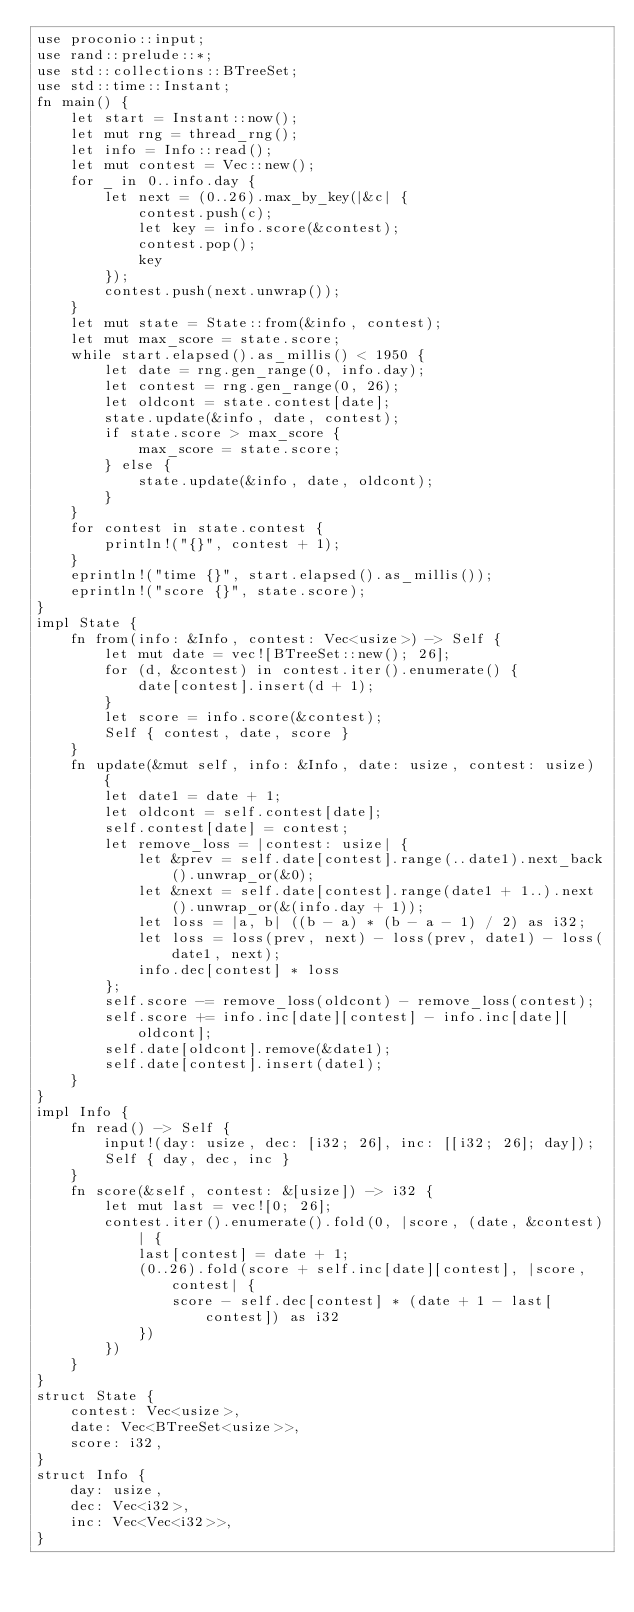Convert code to text. <code><loc_0><loc_0><loc_500><loc_500><_Rust_>use proconio::input;
use rand::prelude::*;
use std::collections::BTreeSet;
use std::time::Instant;
fn main() {
    let start = Instant::now();
    let mut rng = thread_rng();
    let info = Info::read();
    let mut contest = Vec::new();
    for _ in 0..info.day {
        let next = (0..26).max_by_key(|&c| {
            contest.push(c);
            let key = info.score(&contest);
            contest.pop();
            key
        });
        contest.push(next.unwrap());
    }
    let mut state = State::from(&info, contest);
    let mut max_score = state.score;
    while start.elapsed().as_millis() < 1950 {
        let date = rng.gen_range(0, info.day);
        let contest = rng.gen_range(0, 26);
        let oldcont = state.contest[date];
        state.update(&info, date, contest);
        if state.score > max_score {
            max_score = state.score;
        } else {
            state.update(&info, date, oldcont);
        }
    }
    for contest in state.contest {
        println!("{}", contest + 1);
    }
    eprintln!("time {}", start.elapsed().as_millis());
    eprintln!("score {}", state.score);
}
impl State {
    fn from(info: &Info, contest: Vec<usize>) -> Self {
        let mut date = vec![BTreeSet::new(); 26];
        for (d, &contest) in contest.iter().enumerate() {
            date[contest].insert(d + 1);
        }
        let score = info.score(&contest);
        Self { contest, date, score }
    }
    fn update(&mut self, info: &Info, date: usize, contest: usize) {
        let date1 = date + 1;
        let oldcont = self.contest[date];
        self.contest[date] = contest;
        let remove_loss = |contest: usize| {
            let &prev = self.date[contest].range(..date1).next_back().unwrap_or(&0);
            let &next = self.date[contest].range(date1 + 1..).next().unwrap_or(&(info.day + 1));
            let loss = |a, b| ((b - a) * (b - a - 1) / 2) as i32;
            let loss = loss(prev, next) - loss(prev, date1) - loss(date1, next);
            info.dec[contest] * loss
        };
        self.score -= remove_loss(oldcont) - remove_loss(contest);
        self.score += info.inc[date][contest] - info.inc[date][oldcont];
        self.date[oldcont].remove(&date1);
        self.date[contest].insert(date1);
    }
}
impl Info {
    fn read() -> Self {
        input!(day: usize, dec: [i32; 26], inc: [[i32; 26]; day]);
        Self { day, dec, inc }
    }
    fn score(&self, contest: &[usize]) -> i32 {
        let mut last = vec![0; 26];
        contest.iter().enumerate().fold(0, |score, (date, &contest)| {
            last[contest] = date + 1;
            (0..26).fold(score + self.inc[date][contest], |score, contest| {
                score - self.dec[contest] * (date + 1 - last[contest]) as i32
            })
        })
    }
}
struct State {
    contest: Vec<usize>,
    date: Vec<BTreeSet<usize>>,
    score: i32,
}
struct Info {
    day: usize,
    dec: Vec<i32>,
    inc: Vec<Vec<i32>>,
}
</code> 